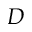Convert formula to latex. <formula><loc_0><loc_0><loc_500><loc_500>D</formula> 